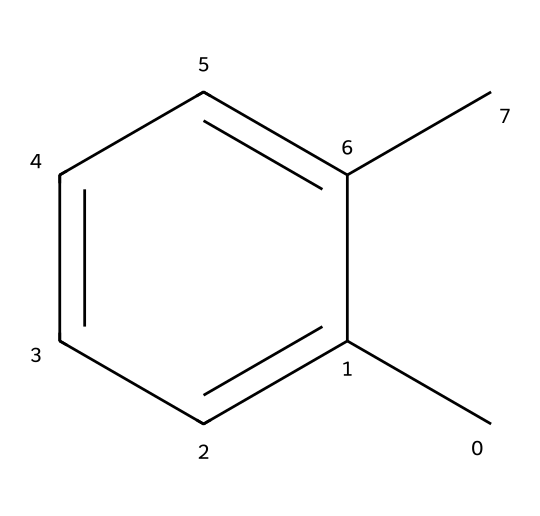How many carbon atoms are in the molecular structure? The SMILES representation "Cc1ccccc1C" indicates the presence of six carbon atoms in the aromatic ring and two additional carbon atoms from the two methyl groups attached to the ring, totaling eight carbon atoms.
Answer: eight What is the chemical name of the substance represented? The structure corresponds to a compound known as xylene, specifically, this structure is for ortho-xylene, which has two methyl groups attached to adjacent carbon atoms on a benzene ring.
Answer: xylene How many hydrogen atoms are bonded to the carbon atoms in the structure? For each carbon atom in xylene, since two carbons are bound by the methyl groups and each carbon in the aromatic structure can typically bond with one hydrogen, the total number of hydrogen atoms is calculated as follows: 2 (from methyl groups) + 4 (from remaining four carbons in the ring) = 8 hydrogen atoms.
Answer: eight What type of functional groups are present in this chemical? The presence of methyl groups (–CH3) attached to the aromatic ring means that the functional group here is an alkyl group, specifically two methyl groups. There are no additional functional groups present in this simple structure.
Answer: alkyl Is this chemical typically used as a solvent? Yes, xylene is commonly used as a solvent in many industrial applications, particularly in paints, varnishes, and wood preservatives, making it suitable for use in wood preservation for vintage pianos.
Answer: yes What type of bonding predominates in this molecule? In this molecule, covalent bonding predominates, as the carbon atoms form bonds with each other and with hydrogen atoms through shared electron pairs, characteristic of organic compounds.
Answer: covalent 